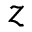<formula> <loc_0><loc_0><loc_500><loc_500>z</formula> 